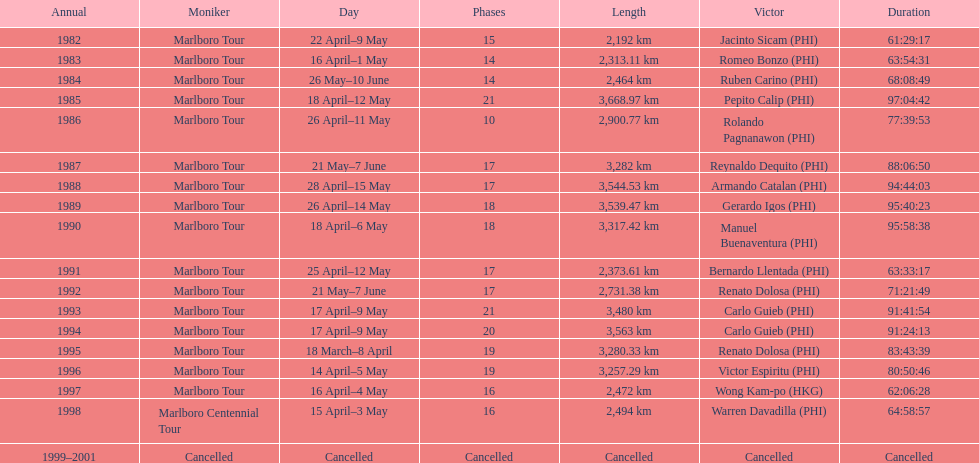During the marlboro tour, what was the maximum distance traveled? 3,668.97 km. 